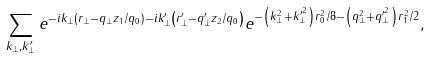<formula> <loc_0><loc_0><loc_500><loc_500>\sum _ { { k } _ { \perp } , { k } _ { \perp } ^ { \prime } } e ^ { - i { k } _ { \perp } \left ( { r } _ { \perp } - { q } _ { \perp } z _ { 1 } / q _ { 0 } \right ) - i { k } ^ { \prime } _ { \perp } \left ( { r } ^ { \prime } _ { \perp } - { q } ^ { \prime } _ { \perp } z _ { 2 } / q _ { 0 } \right ) } e ^ { - \left ( k ^ { 2 } _ { \perp } + k ^ { \prime ^ { 2 } } _ { \perp } \right ) r _ { 0 } ^ { 2 } / 8 - \left ( q ^ { 2 } _ { \perp } + q ^ { \prime ^ { 2 } } _ { \perp } \right ) r _ { 1 } ^ { 2 } / 2 } ,</formula> 